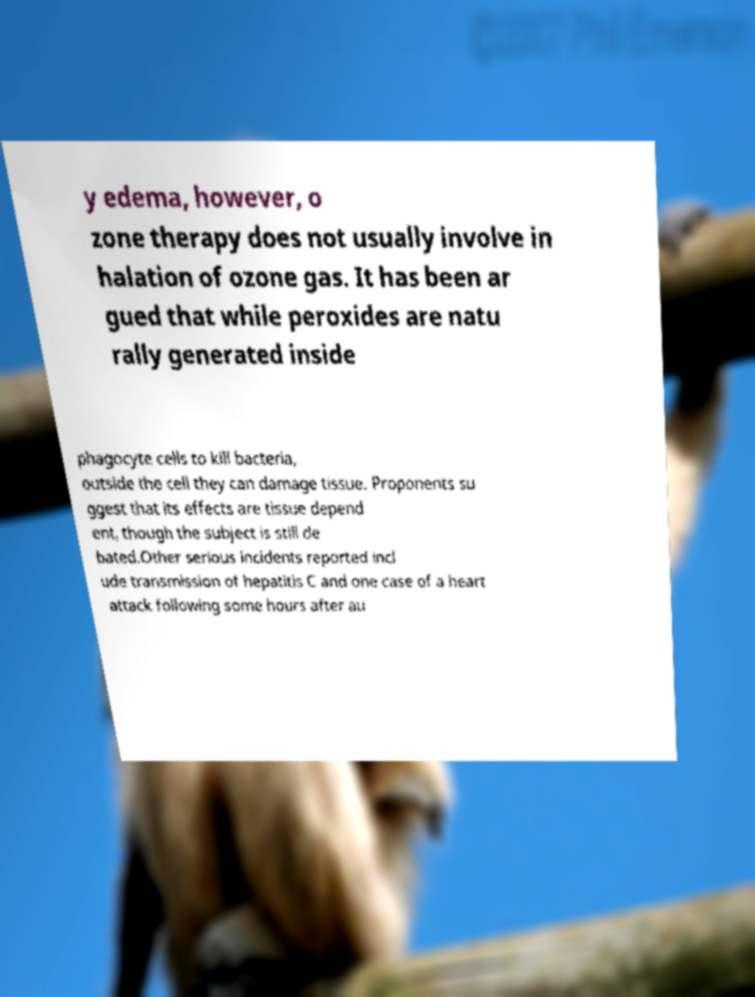There's text embedded in this image that I need extracted. Can you transcribe it verbatim? y edema, however, o zone therapy does not usually involve in halation of ozone gas. It has been ar gued that while peroxides are natu rally generated inside phagocyte cells to kill bacteria, outside the cell they can damage tissue. Proponents su ggest that its effects are tissue depend ent, though the subject is still de bated.Other serious incidents reported incl ude transmission of hepatitis C and one case of a heart attack following some hours after au 